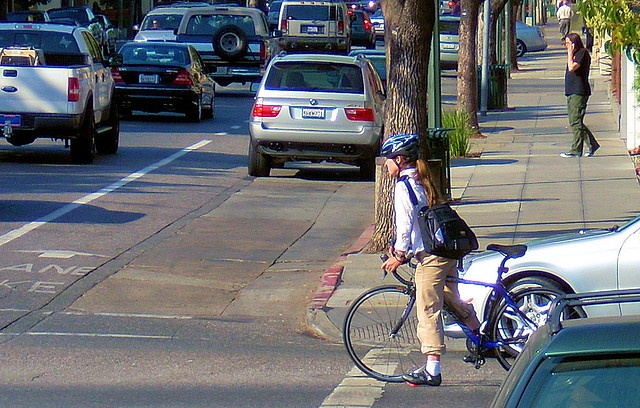Describe the objects in this image and their specific colors. I can see bicycle in black, darkgray, gray, and white tones, truck in black, navy, and gray tones, car in black, darkgray, gray, and white tones, car in black, blue, gray, and darkgray tones, and car in black, white, lightblue, and darkgray tones in this image. 